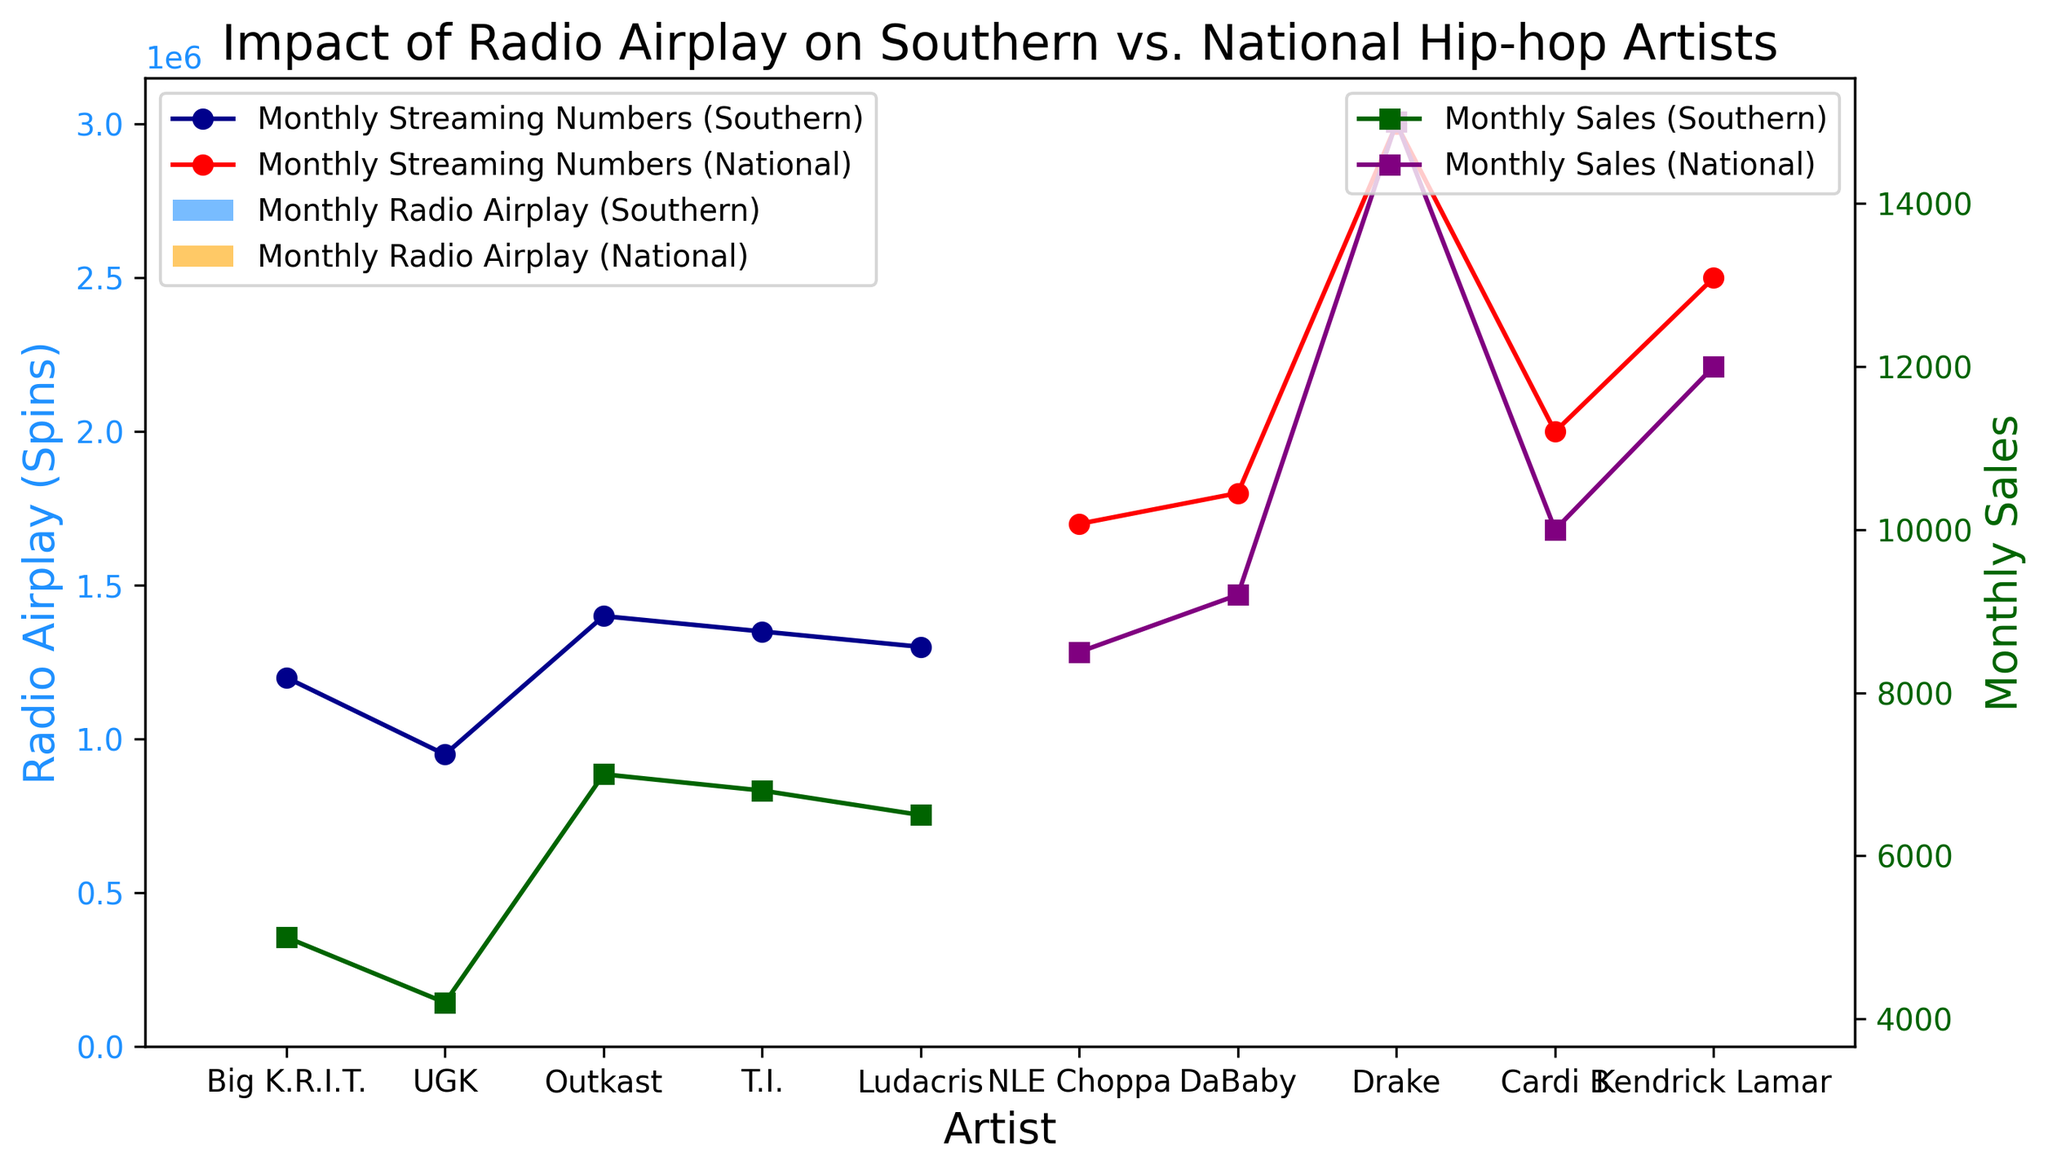What's the artist with the highest Monthly Sales from the Southern region? Look at the Southern Hip-hop artists and check the blue bar plot (Radio Airplay) and the green line plot (Monthly Sales). Outkast has the highest Monthly Sales among Southern artists with 7,000 sales.
Answer: Outkast Which artist has the highest Monthly Radio Airplay in the National region? Look at the yellow (orange) bars for Monthly Radio Airplay in the National region. Drake has the highest Monthly Radio Airplay with 1,500 spins.
Answer: Drake What is the average Monthly Streaming Numbers for Southern artists? Add the Monthly Streaming Numbers for all Southern artists: 1200000 (Big K.R.I.T.) + 950000 (UGK) + 1400000 (Outkast) + 1350000 (T.I.) + 1300000 (Ludacris) = 6200000. Then divide by the number of Southern artists (5). 6200000 / 5 = 1240000.
Answer: 1240000 Compare the Monthly Sales of Outkast and Kendrick Lamar. Who has higher sales and by how much? Outkast (Southern) has Monthly Sales of 7,000, and Kendrick Lamar (National) has Monthly Sales of 12,000. Subtract Outkast's sales from Kendrick Lamar's sales: 12000 - 7000 = 5000. Kendrick Lamar has higher sales by 5,000.
Answer: Kendrick Lamar by 5000 Which Southern artist has the lowest Monthly Radio Airplay and how many spins do they have? Among the Southern artists, UGK has the lowest Monthly Radio Airplay with 620 spins.
Answer: UGK with 620 spins Who has higher Monthly Streaming Numbers, T.I. or DaBaby, and by how much? T.I. has Monthly Streaming Numbers of 1,350,000 and DaBaby has 1,800,000. Subtract T.I.'s streaming numbers from DaBaby's: 1800000 - 1350000 = 450000. DaBaby has higher streaming numbers by 450,000.
Answer: DaBaby by 450000 What is the color indicating Monthly Sales for National artists? Look at the purple lines, which represent Monthly Sales for National artists. The purple color shows these lines.
Answer: Purple Compare the Monthly Radio Airplay of NLE Choppa and Big K.R.I.T., and state the difference. NLE Choppa has 1,000 spins while Big K.R.I.T. has 750 spins. Subtract Big K.R.I.T's spins from NLE Choppa's: 1000 - 750 = 250. NLE Choppa has 250 more spins.
Answer: 250 Which region, Southern or National, has the artist with the highest Monthly Streaming Numbers? Check the red and blue lines representing Monthly Streaming Numbers for each region. Drake, from the National region, has 3,000,000 streaming numbers, the highest in the chart.
Answer: National How does the Monthly Radio Airplay of Cardi B compare to Ludacris, and who leads? Cardi B has 1,200 spins and Ludacris has 800 spins. Cardi B leads with 400 more spins.
Answer: Cardi B by 400 